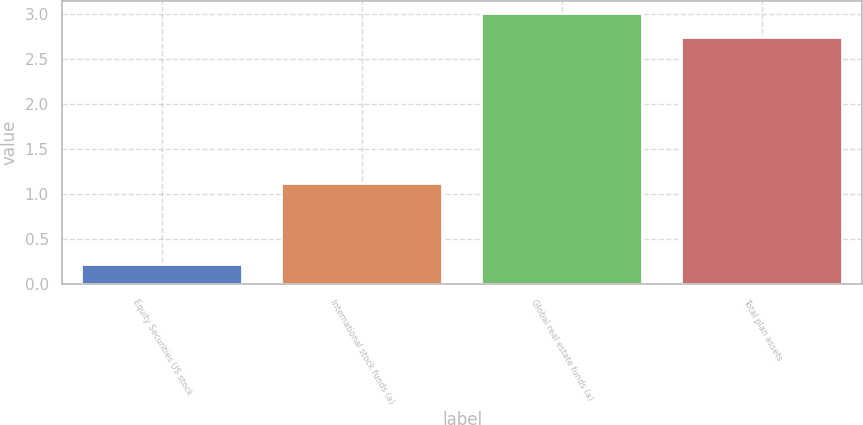<chart> <loc_0><loc_0><loc_500><loc_500><bar_chart><fcel>Equity Securities US stock<fcel>International stock funds (a)<fcel>Global real estate funds (a)<fcel>Total plan assets<nl><fcel>0.22<fcel>1.11<fcel>3<fcel>2.74<nl></chart> 